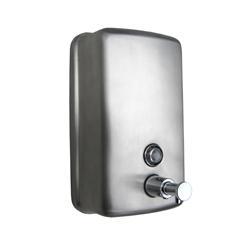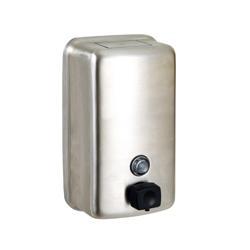The first image is the image on the left, the second image is the image on the right. Examine the images to the left and right. Is the description "The dispenser on the right has a black base." accurate? Answer yes or no. No. 